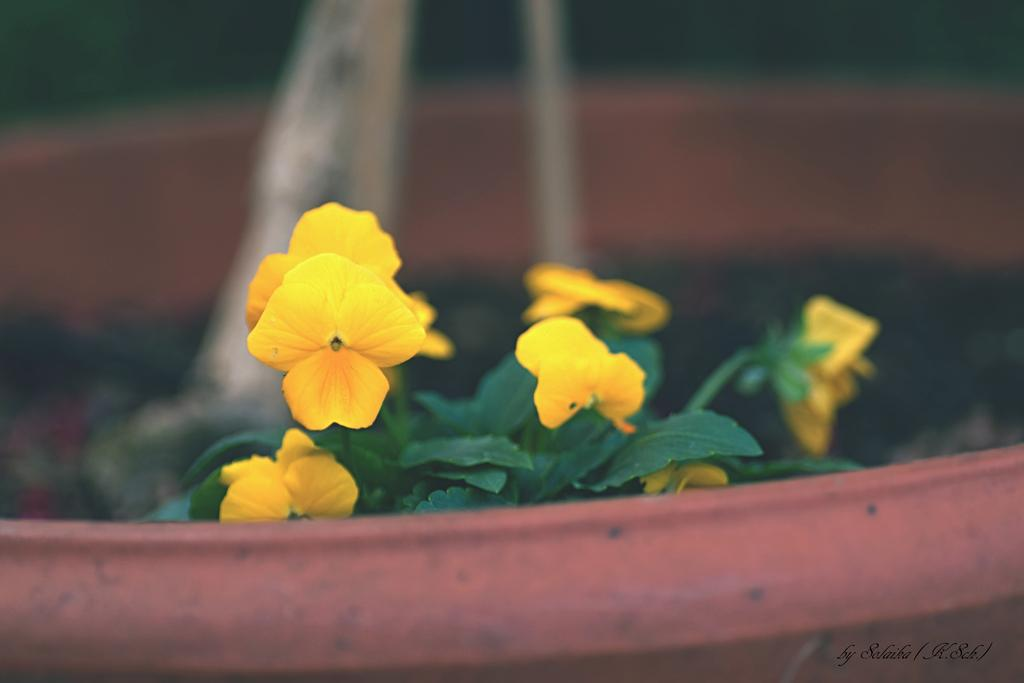What type of photography is used in the image? The image is a macro photography. What is the main subject of the image? The subject of the image is flowers. Where do the flowers in the image come from? The flowers are from a potted plant. What type of flag is visible in the image? There is no flag present in the image; it features macro photography of flowers from a potted plant. 